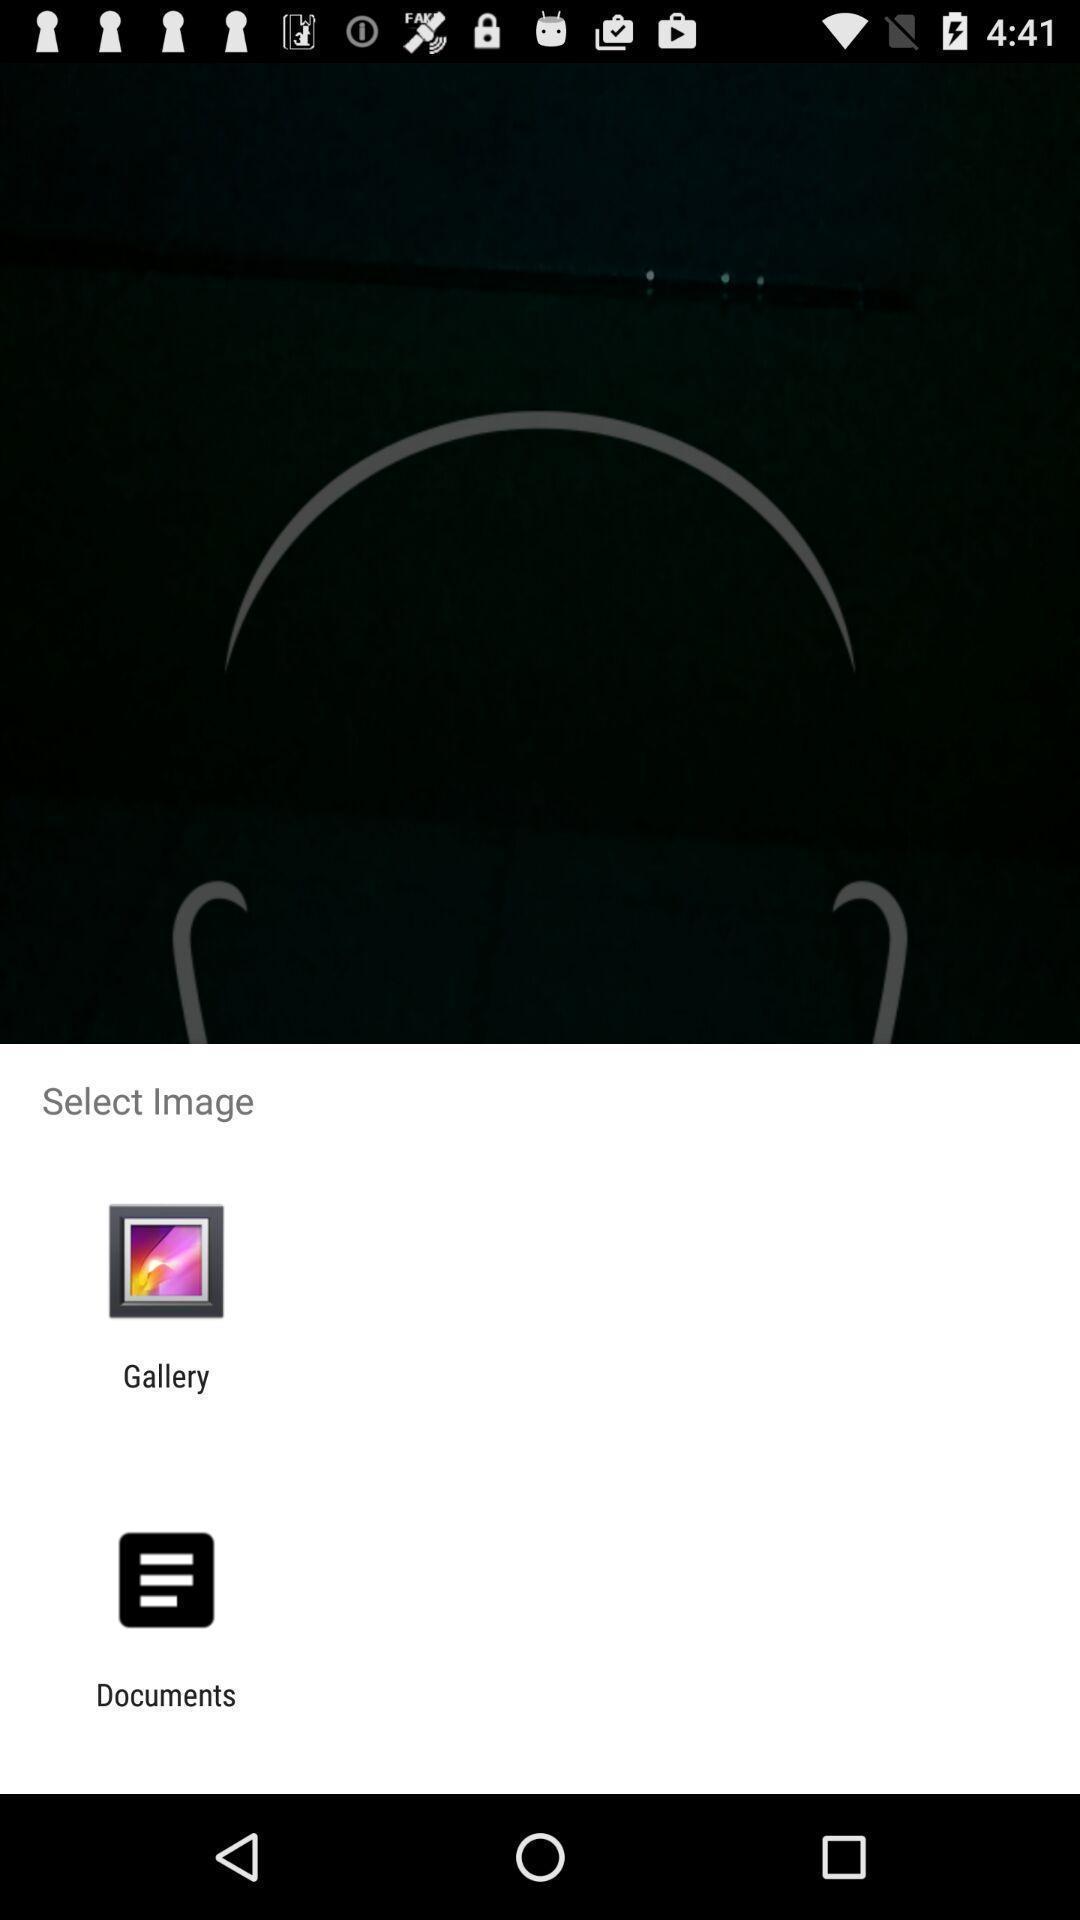What can you discern from this picture? Pop-up displaying the app options to open an image. 